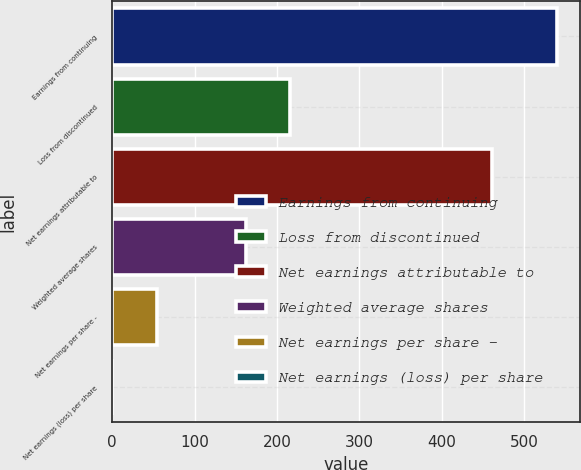Convert chart. <chart><loc_0><loc_0><loc_500><loc_500><bar_chart><fcel>Earnings from continuing<fcel>Loss from discontinued<fcel>Net earnings attributable to<fcel>Weighted average shares<fcel>Net earnings per share -<fcel>Net earnings (loss) per share<nl><fcel>540.4<fcel>216.31<fcel>461.2<fcel>162.3<fcel>54.28<fcel>0.27<nl></chart> 